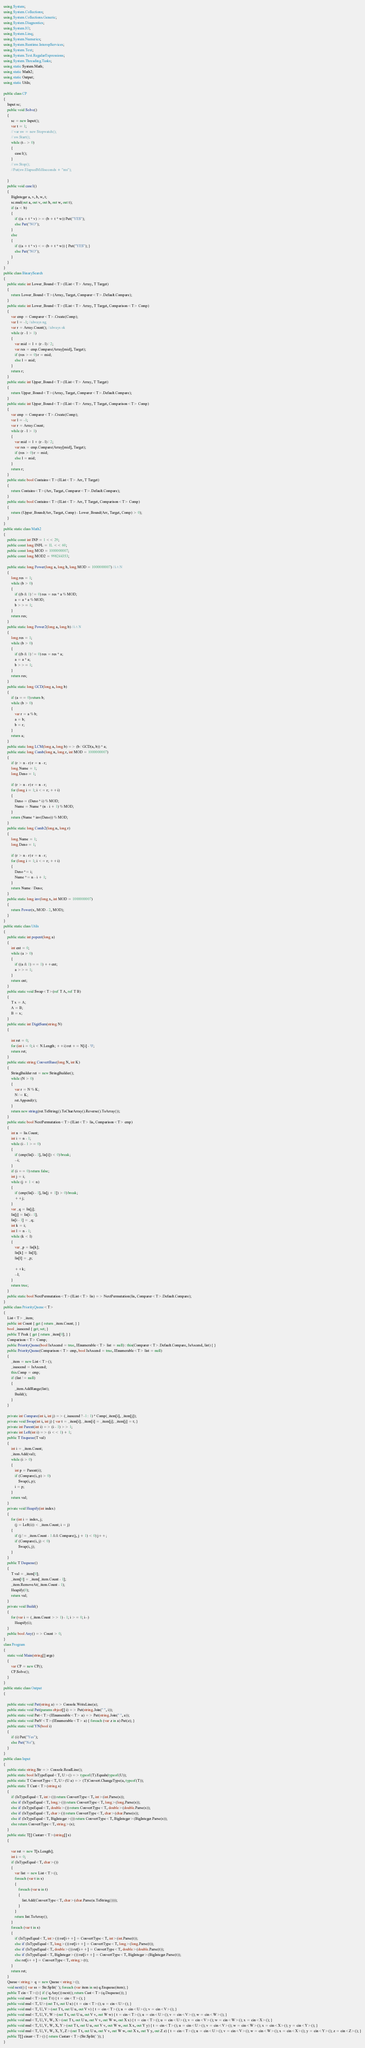Convert code to text. <code><loc_0><loc_0><loc_500><loc_500><_C#_>using System;
using System.Collections;
using System.Collections.Generic;
using System.Diagnostics;
using System.IO;
using System.Linq;
using System.Numerics;
using System.Runtime.InteropServices;
using System.Text;
using System.Text.RegularExpressions;
using System.Threading.Tasks;
using static System.Math;
using static Math2;
using static Output;
using static Utils;

public class CP
{
    Input sc;
    public void Solve()
    {
        sc = new Input();
        var t = 1;
        // var sw = new Stopwatch();
        // sw.Start();
        while (t-- > 0)
        {
            case1();
        }
        // sw.Stop();
        //Put(sw.ElapsedMilliseconds + "ms");

    }
    public void case1()
    {
        BigInteger a, v, b, w, t;
        sc.mul(out a, out v, out b, out w, out t);
        if (a < b)
        {
            if ((a + t * v) >= (b + t * w)) Put("YES");
            else Put("NO");
        }
        else
        {
            if ((a + t * v) <= (b + t * w)) { Put("YES"); }
            else Put("NO");
        }
    }
}
public class BinarySearch
{
    public static int Lower_Bound<T>(IList<T> Array, T Target)
    {
        return Lower_Bound<T>(Array, Target, Comparer<T>.Default.Compare);
    }
    public static int Lower_Bound<T>(IList<T> Array, T Target, Comparison<T> Comp)
    {
        var cmp = Comparer<T>.Create(Comp);
        var l = -1; //always ng
        var r = Array.Count(); //always ok
        while (r - l > 1)
        {
            var mid = l + (r - l) / 2;
            var res = cmp.Compare(Array[mid], Target);
            if (res >= 0) r = mid;
            else l = mid;
        }
        return r;
    }
    public static int Upper_Bound<T>(IList<T> Array, T Target)
    {
        return Upper_Bound<T>(Array, Target, Comparer<T>.Default.Compare);
    }
    public static int Upper_Bound<T>(IList<T> Array, T Target, Comparison<T> Comp)
    {
        var cmp = Comparer<T>.Create(Comp);
        var l = -1;
        var r = Array.Count;
        while (r - l > 1)
        {
            var mid = l + (r - l) / 2;
            var res = cmp.Compare(Array[mid], Target);
            if (res > 0) r = mid;
            else l = mid;
        }
        return r;
    }
    public static bool Contains<T>(IList<T> Arr, T Target)
    {
        return Contains<T>(Arr, Target, Comparer<T>.Default.Compare);
    }
    public static bool Contains<T>(IList<T> Arr, T Target, Comparison<T> Comp)
    {
        return (Upper_Bound(Arr, Target, Comp) - Lower_Bound(Arr, Target, Comp) > 0);
    }
}
public static class Math2
{
    public const int INF = 1 << 29;
    public const long INFL = 1L << 60;
    public const long MOD = 1000000007;
    public const long MOD2 = 998244353;

    public static long Power(long a, long b, long MOD = 1000000007) //i^N
    {
        long res = 1;
        while (b > 0)
        {
            if ((b & 1) != 0) res = res * a % MOD;
            a = a * a % MOD;
            b >>= 1;
        }
        return res;
    }
    public static long Power2(long a, long b) //i^N
    {
        long res = 1;
        while (b > 0)
        {
            if ((b & 1) != 0) res = res * a;
            a = a * a;
            b >>= 1;
        }
        return res;
    }
    public static long GCD(long a, long b)
    {
        if (a == 0) return b;
        while (b > 0)
        {
            var r = a % b;
            a = b;
            b = r;
        }
        return a;
    }
    public static long LCM(long a, long b) => (b / GCD(a, b)) * a;
    public static long Comb(long n, long r, int MOD = 1000000007)
    {
        if (r > n - r) r = n - r;
        long Nume = 1;
        long Deno = 1;

        if (r > n - r) r = n - r;
        for (long i = 1; i <= r; ++i)
        {
            Deno = (Deno * i) % MOD;
            Nume = Nume * (n - i + 1) % MOD;
        }
        return (Nume * inv(Deno)) % MOD;
    }
    public static long Comb2(long n, long r)
    {
        long Nume = 1;
        long Deno = 1;

        if (r > n - r) r = n - r;
        for (long i = 1; i <= r; ++i)
        {
            Deno *= i;
            Nume *= n - i + 1;
        }
        return Nume / Deno;
    }
    public static long inv(long x, int MOD = 1000000007)
    {
        return Power(x, MOD - 2, MOD);
    }
}
public static class Utils
{
    public static int popcnt(long a)
    {
        int cnt = 0;
        while (a > 0)
        {
            if ((a & 1) == 1) ++cnt;
            a >>= 1;
        }
        return cnt;
    }
    public static void Swap<T>(ref T A, ref T B)
    {
        T x = A;
        A = B;
        B = x;
    }
    public static int DigitSum(string N)
    {

        int ret = 0;
        for (int i = 0; i < N.Length; ++i) ret += N[i] - '0';
        return ret;
    }
    public static string ConvertBase(long N, int K)
    {
        StringBuilder ret = new StringBuilder();
        while (N > 0)
        {
            var r = N % K;
            N /= K;
            ret.Append(r);
        }
        return new string(ret.ToString().ToCharArray().Reverse().ToArray());
    }
    public static bool NextPermutation<T>(IList<T> lis, Comparison<T> cmp)
    {
        int n = lis.Count;
        int i = n - 1;
        while (i - 1 >= 0)
        {
            if (cmp(lis[i - 1], lis[i]) < 0) break;
            --i;
        }
        if (i == 0) return false;
        int j = i;
        while (j + 1 < n)
        {
            if (cmp(lis[i - 1], lis[j + 1]) > 0) break;
            ++j;
        }
        var _q = lis[j];
        lis[j] = lis[i - 1];
        lis[i - 1] = _q;
        int k = i;
        int l = n - 1;
        while (k < l)
        {
            var _p = lis[k];
            lis[k] = lis[l];
            lis[l] = _p;

            ++k;
            --l;
        }
        return true;
    }
    public static bool NextPermutation<T>(IList<T> lis) => NextPermutation(lis, Comparer<T>.Default.Compare);
}
public class PriorityQueue<T>
{
    List<T> _item;
    public int Count { get { return _item.Count; } }
    bool _isascend { get; set; }
    public T Peek { get { return _item[0]; } }
    Comparison<T> Comp;
    public PriorityQueue(bool IsAscend = true, IEnumerable<T> list = null) : this(Comparer<T>.Default.Compare, IsAscend, list) { }
    public PriorityQueue(Comparison<T> cmp, bool IsAscend = true, IEnumerable<T> list = null)
    {
        _item = new List<T>();
        _isascend = IsAscend;
        this.Comp = cmp;
        if (list != null)
        {
            _item.AddRange(list);
            Build();
        }
    }

    private int Compare(int i, int j) => (_isascend ? -1 : 1) * Comp(_item[i], _item[j]);
    private void Swap(int i, int j) { var t = _item[i]; _item[i] = _item[j]; _item[j] = t; }
    private int Parent(int i) => (i - 1) >> 1;
    private int Left(int i) => (i << 1) + 1;
    public T Enqueue(T val)
    {
        int i = _item.Count;
        _item.Add(val);
        while (i > 0)
        {
            int p = Parent(i);
            if (Compare(i, p) > 0)
                Swap(i, p);
            i = p;
        }
        return val;
    }
    private void Heapify(int index)
    {
        for (int i = index, j;
            (j = Left(i)) < _item.Count; i = j)
        {
            if (j != _item.Count - 1 && Compare(j, j + 1) < 0) j++;
            if (Compare(i, j) < 0)
                Swap(i, j);
        }
    }
    public T Dequeue()
    {
        T val = _item[0];
        _item[0] = _item[_item.Count - 1];
        _item.RemoveAt(_item.Count - 1);
        Heapify(0);
        return val;
    }
    private void Build()
    {
        for (var i = (_item.Count >> 1) - 1; i >= 0; i--)
            Heapify(i);
    }
    public bool Any() => Count > 0;
}
class Program
{
    static void Main(string[] args)
    {
        var CP = new CP();
        CP.Solve();
    }
}
public static class Output
{

    public static void Put(string a) => Console.WriteLine(a);
    public static void Put(params object[] i) => Put(string.Join(" ", i));
    public static void Put<T>(IEnumerable<T> a) => Put(string.Join(" ", a));
    public static void PutV<T>(IEnumerable<T> a) { foreach (var z in a) Put(z); }
    public static void YN(bool i)
    {
        if (i) Put("Yes");
        else Put("No");
    }
}
public class Input
{
    public static string Str => Console.ReadLine();
    public static bool IsTypeEqual<T, U>() => typeof(T).Equals(typeof(U));
    public static T ConvertType<T, U>(U a) => (T)Convert.ChangeType(a, typeof(T));
    public static T Cast<T>(string s)
    {
        if (IsTypeEqual<T, int>()) return ConvertType<T, int>(int.Parse(s));
        else if (IsTypeEqual<T, long>()) return ConvertType<T, long>(long.Parse(s));
        else if (IsTypeEqual<T, double>()) return ConvertType<T, double>(double.Parse(s));
        else if (IsTypeEqual<T, char>()) return ConvertType<T, char>(char.Parse(s));
        else if (IsTypeEqual<T, BigInteger>()) return ConvertType<T, BigInteger>(BigInteger.Parse(s));
        else return ConvertType<T, string>(s);
    }
    public static T[] Castarr<T>(string[] s)
    {

        var ret = new T[s.Length];
        int i = 0;
        if (IsTypeEqual<T, char>())
        {
            var list = new List<T>();
            foreach (var t in s)
            {
                foreach (var u in t)
                {
                    list.Add(ConvertType<T, char>(char.Parse(u.ToString())));
                }
            }
            return list.ToArray();
        }
        foreach (var t in s)
        {
            if (IsTypeEqual<T, int>()) ret[i++] = ConvertType<T, int>(int.Parse(t));
            else if (IsTypeEqual<T, long>()) ret[i++] = ConvertType<T, long>(long.Parse(t));
            else if (IsTypeEqual<T, double>()) ret[i++] = ConvertType<T, double>(double.Parse(t));
            else if (IsTypeEqual<T, BigInteger>()) ret[i++] = ConvertType<T, BigInteger>(BigInteger.Parse(t));
            else ret[i++] = ConvertType<T, string>(t);
        }
        return ret;
    }
    Queue<string> q = new Queue<string>();
    void next() { var ss = Str.Split(' '); foreach (var item in ss) q.Enqueue(item); }
    public T cin<T>() { if (!q.Any()) next(); return Cast<T>(q.Dequeue()); }
    public void mul<T>(out T t) { t = cin<T>(); }
    public void mul<T, U>(out T t, out U u) { t = cin<T>(); u = cin<U>(); }
    public void mul<T, U, V>(out T t, out U u, out V v) { t = cin<T>(); u = cin<U>(); v = cin<V>(); }
    public void mul<T, U, V, W>(out T t, out U u, out V v, out W w) { t = cin<T>(); u = cin<U>(); v = cin<V>(); w = cin<W>(); }
    public void mul<T, U, V, W, X>(out T t, out U u, out V v, out W w, out X x) { t = cin<T>(); u = cin<U>(); v = cin<V>(); w = cin<W>(); x = cin<X>(); }
    public void mul<T, U, V, W, X, Y>(out T t, out U u, out V v, out W w, out X x, out Y y) { t = cin<T>(); u = cin<U>(); v = cin<V>(); w = cin<W>(); x = cin<X>(); y = cin<Y>(); }
    public void mul<T, U, V, W, X, Y, Z>(out T t, out U u, out V v, out W w, out X x, out Y y, out Z z) { t = cin<T>(); u = cin<U>(); v = cin<V>(); w = cin<W>(); x = cin<X>(); y = cin<Y>(); z = cin<Z>(); }
    public T[] cinarr<T>() { return Castarr<T>(Str.Split(' ')); }
}</code> 